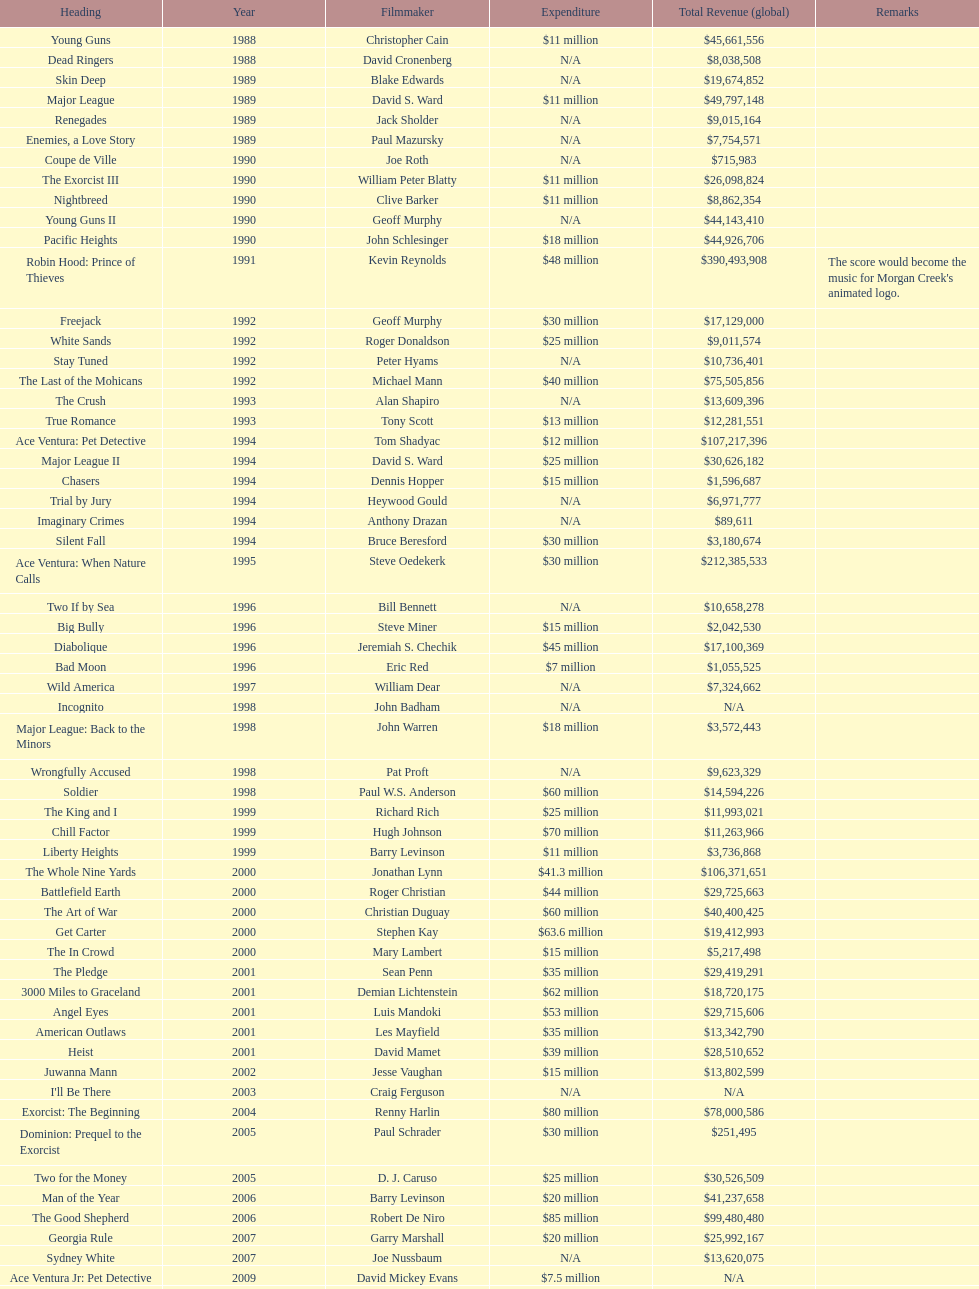Was the budget for young guns more or less than freejack's budget? Less. 